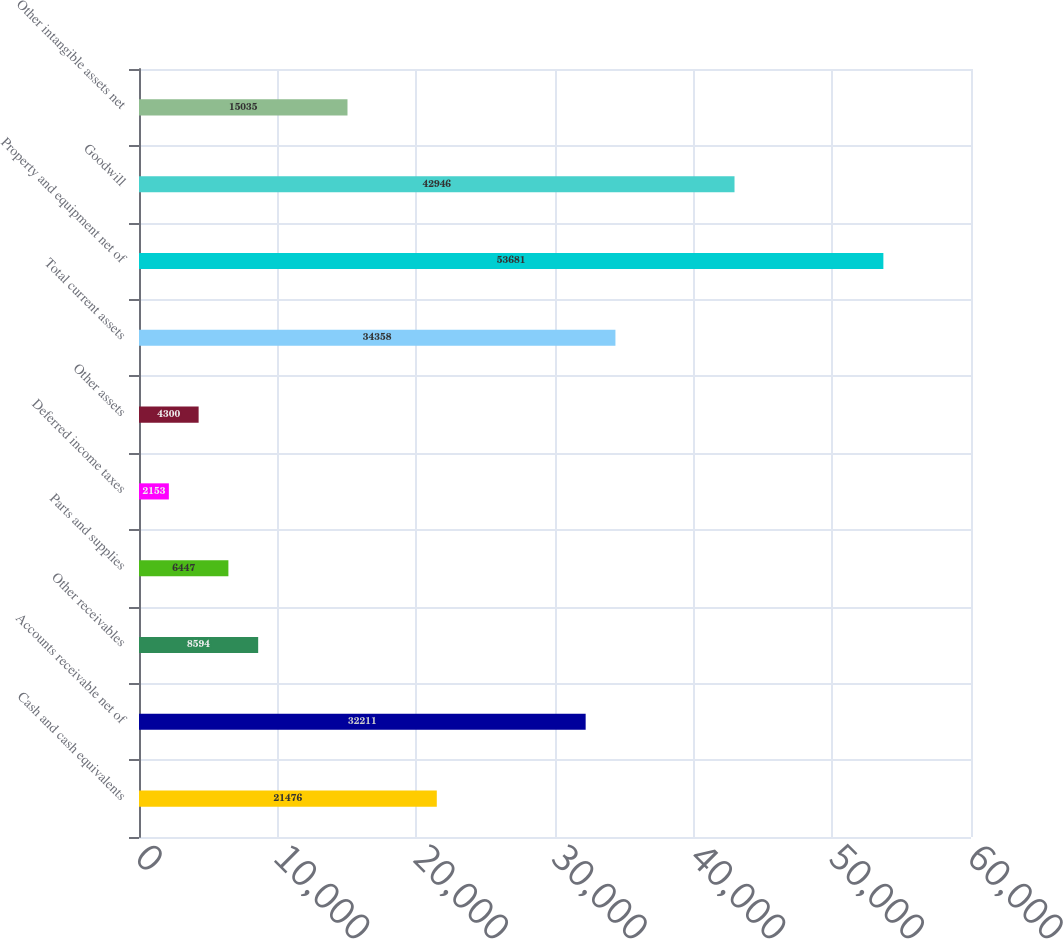Convert chart. <chart><loc_0><loc_0><loc_500><loc_500><bar_chart><fcel>Cash and cash equivalents<fcel>Accounts receivable net of<fcel>Other receivables<fcel>Parts and supplies<fcel>Deferred income taxes<fcel>Other assets<fcel>Total current assets<fcel>Property and equipment net of<fcel>Goodwill<fcel>Other intangible assets net<nl><fcel>21476<fcel>32211<fcel>8594<fcel>6447<fcel>2153<fcel>4300<fcel>34358<fcel>53681<fcel>42946<fcel>15035<nl></chart> 